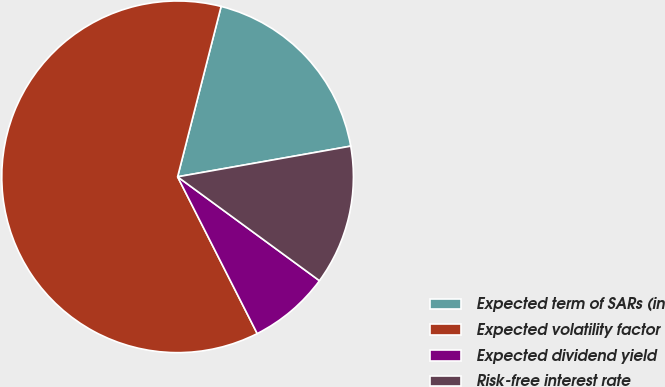Convert chart. <chart><loc_0><loc_0><loc_500><loc_500><pie_chart><fcel>Expected term of SARs (in<fcel>Expected volatility factor<fcel>Expected dividend yield<fcel>Risk-free interest rate<nl><fcel>18.23%<fcel>61.46%<fcel>7.46%<fcel>12.85%<nl></chart> 